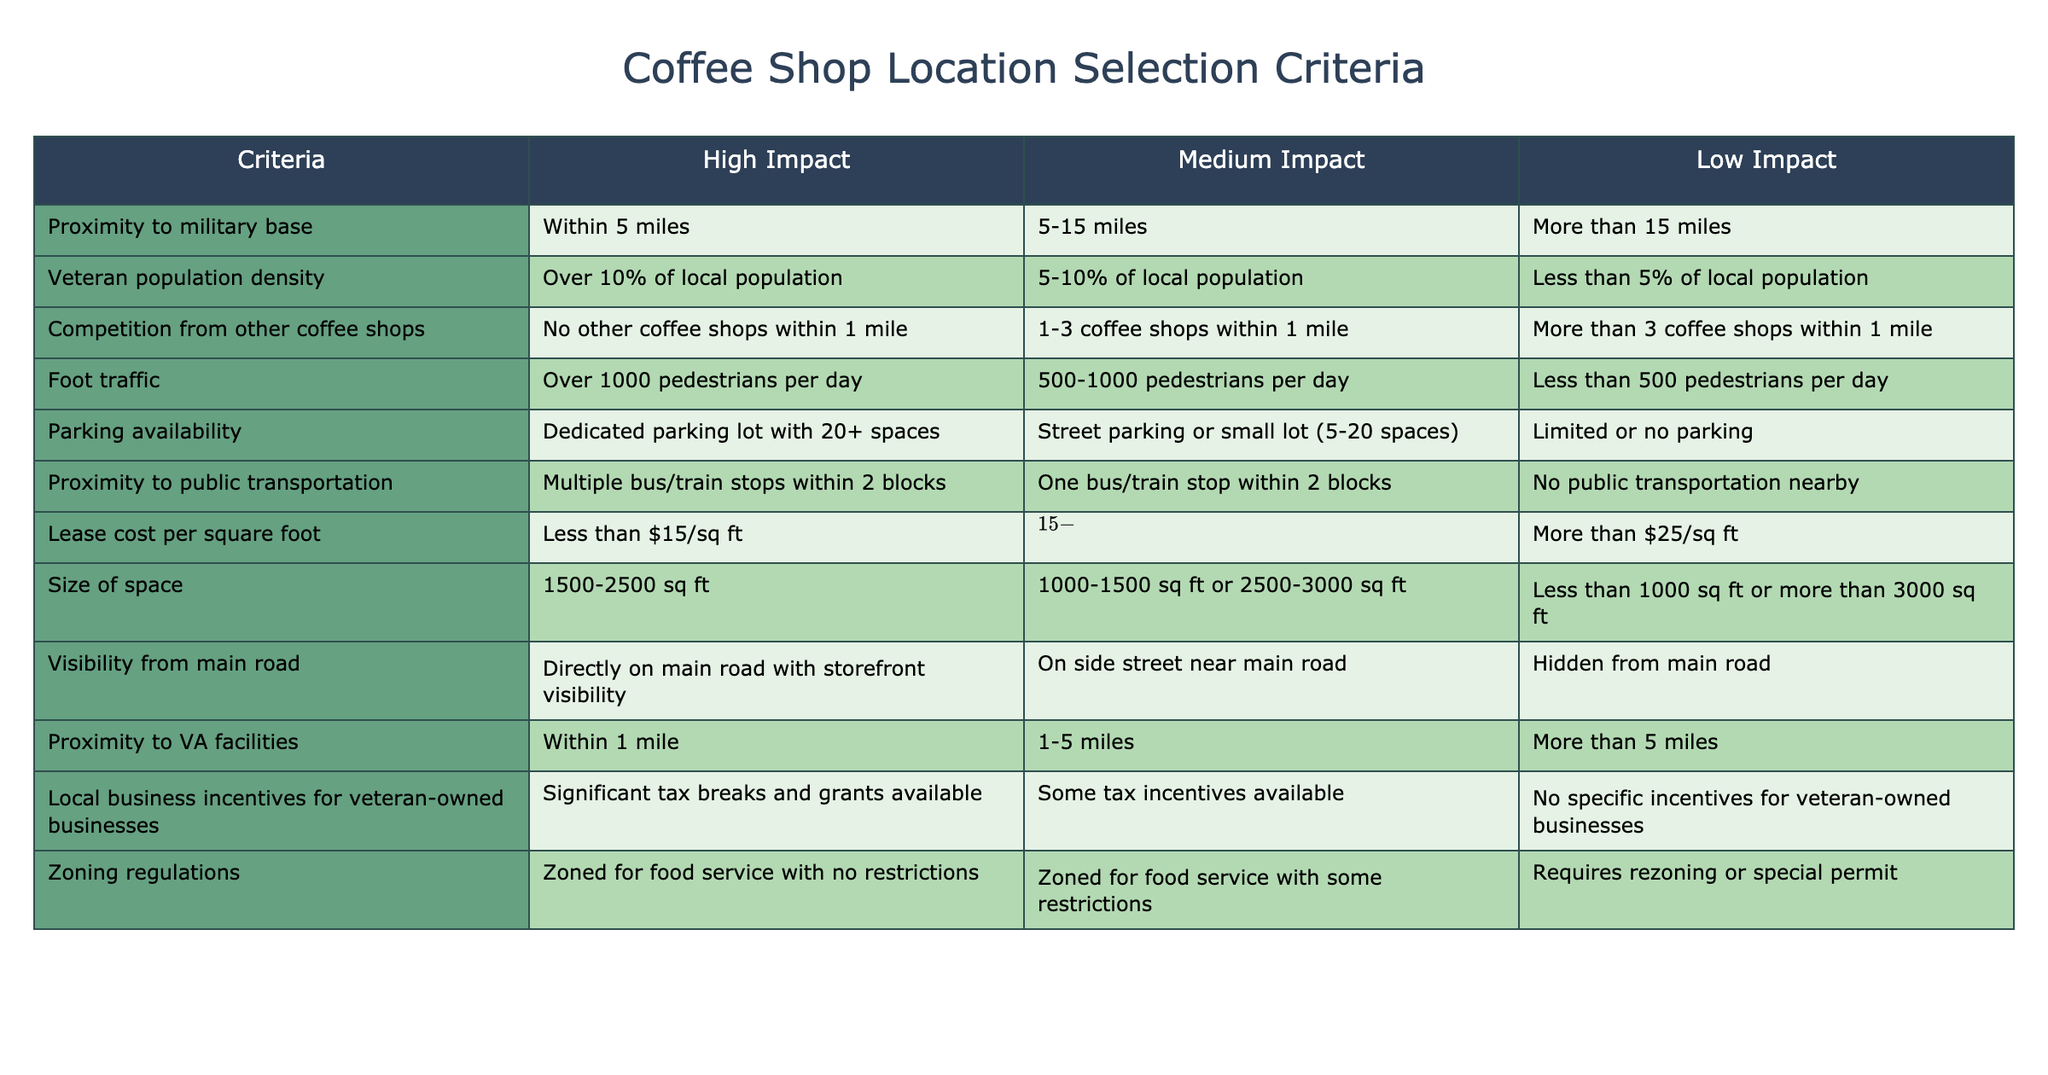What is considered high impact for proximity to military base? According to the table, the high impact criterion for proximity to a military base is defined as being within 5 miles.
Answer: Within 5 miles How many parking spaces are required for high impact parking availability? The high impact criterion for parking availability requires a dedicated parking lot with 20 or more spaces, as stated in the table.
Answer: 20 or more spaces Is there a specific lease cost range considered low impact? Yes, the table indicates that a lease cost of more than 25 dollars per square foot is considered low impact.
Answer: Yes What is the maximum distance from a VA facility for medium impact? The table specifies that a medium impact proximity to VA facilities is within 1 to 5 miles.
Answer: 1 to 5 miles How does foot traffic impact coffee shop location selection? High impact foot traffic is categorized as over 1000 pedestrians per day, while medium impact is between 500 to 1000, indicating that higher foot traffic is more favorable for location selection.
Answer: Higher foot traffic is favorable What is the average parking availability when considering both high and medium impact criteria? Since high impact is defined as 20 or more dedicated spaces and medium impact as 5 to 20 spaces, the average can be calculated as the midpoint of these ranges. Assuming 20 for high and the average of 5 to 20 is 12.5, the average would be (20 + 12.5) / 2 = 16.25 spaces.
Answer: 16.25 spaces Are there any local business incentives for veteran-owned businesses categorized as low impact? Yes, the table indicates that low impact criteria for local business incentives state there are no specific incentives for veteran-owned businesses.
Answer: Yes If a location has 3 coffee shops within 1 mile, what impact category does it fall into? The presence of more than 3 coffee shops within 1 mile places the location in the low impact category according to the table.
Answer: Low impact What is the combined impact of high proximity to military base and high veteran population density? High proximity to a military base is within 5 miles and high veteran population density is over 10% of the local population, both of which suggest a favorable location to serve veterans effectively. This combination supports a strategic advantage for attracting this demographic.
Answer: Strategic advantage for attracting veterans 